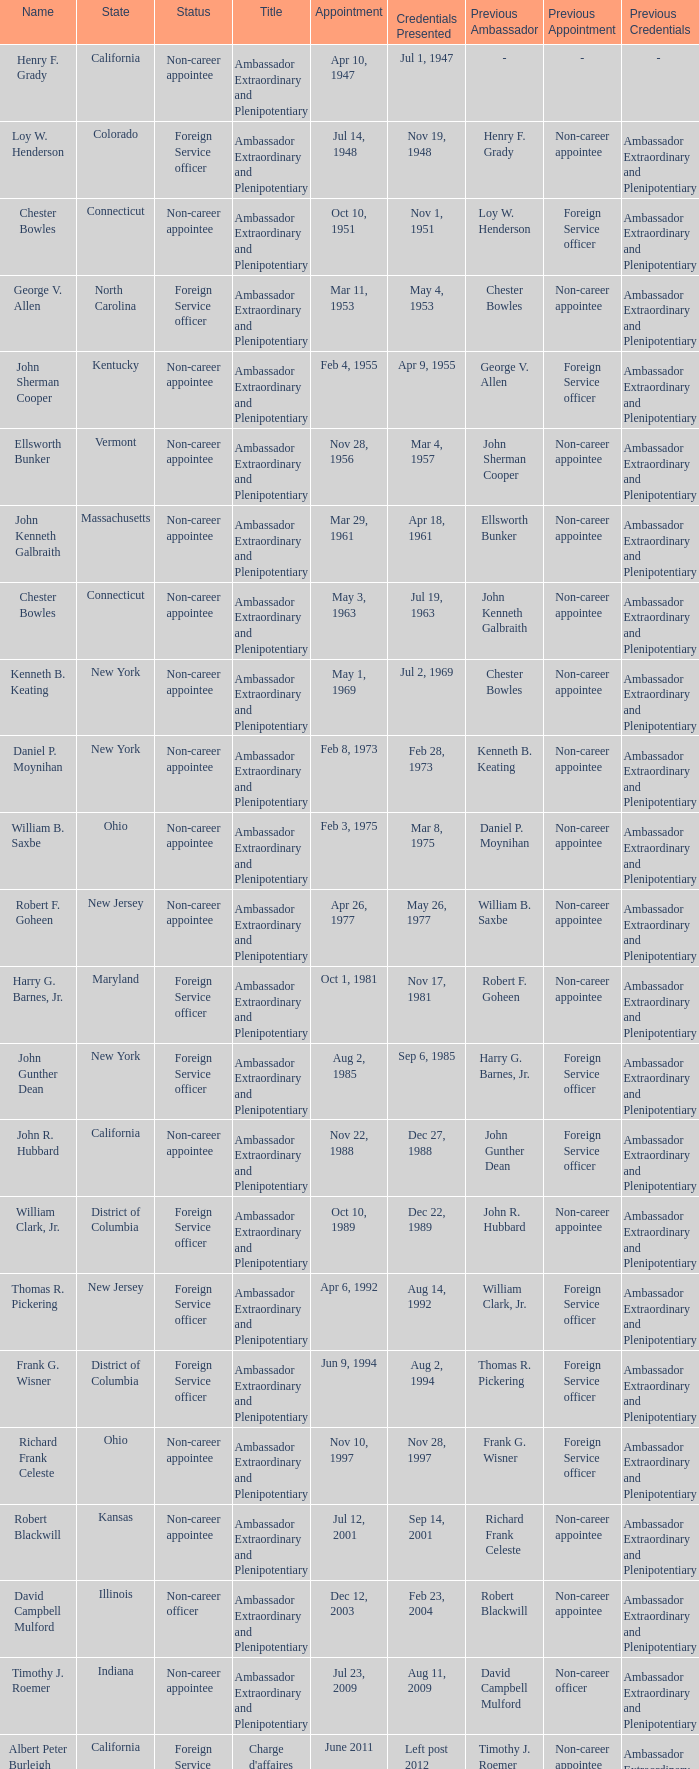When were the certificates presented for new jersey with a status of foreign service officer? Aug 14, 1992. 